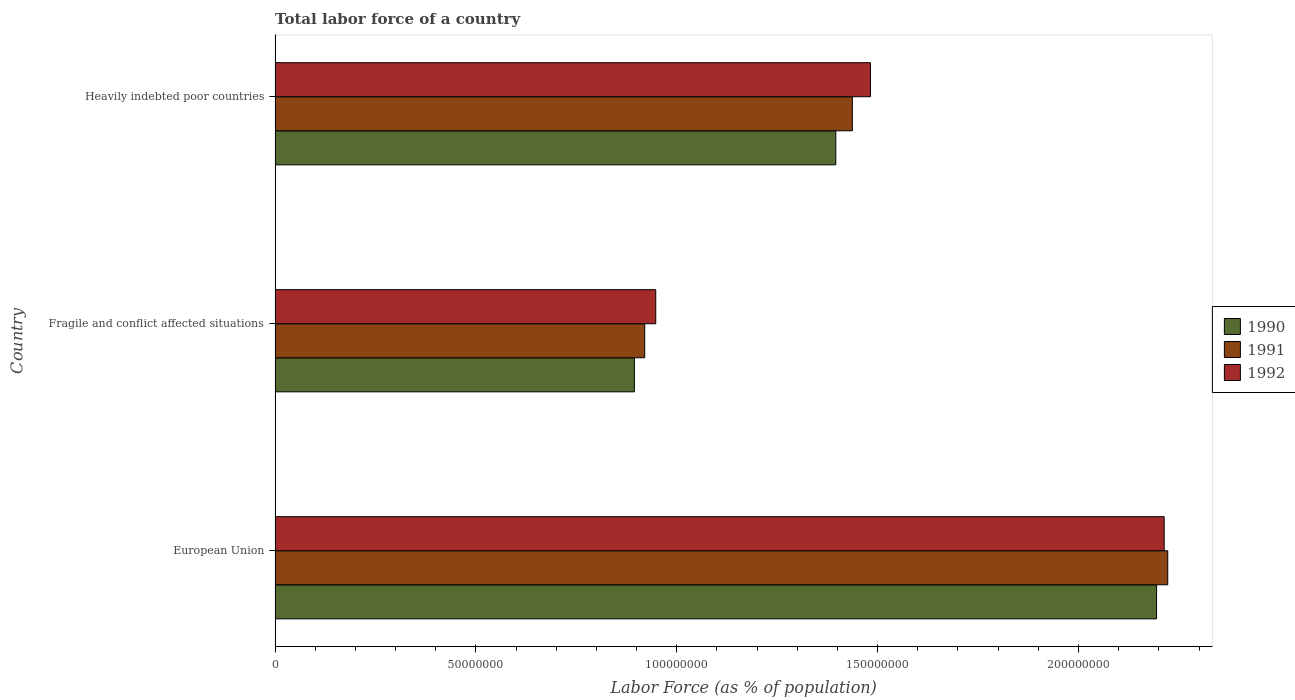Are the number of bars per tick equal to the number of legend labels?
Your response must be concise. Yes. Are the number of bars on each tick of the Y-axis equal?
Offer a terse response. Yes. How many bars are there on the 2nd tick from the top?
Make the answer very short. 3. How many bars are there on the 1st tick from the bottom?
Ensure brevity in your answer.  3. What is the percentage of labor force in 1992 in Fragile and conflict affected situations?
Provide a succinct answer. 9.48e+07. Across all countries, what is the maximum percentage of labor force in 1990?
Provide a succinct answer. 2.19e+08. Across all countries, what is the minimum percentage of labor force in 1991?
Offer a very short reply. 9.20e+07. In which country was the percentage of labor force in 1990 minimum?
Ensure brevity in your answer.  Fragile and conflict affected situations. What is the total percentage of labor force in 1990 in the graph?
Ensure brevity in your answer.  4.48e+08. What is the difference between the percentage of labor force in 1990 in European Union and that in Fragile and conflict affected situations?
Keep it short and to the point. 1.30e+08. What is the difference between the percentage of labor force in 1990 in European Union and the percentage of labor force in 1991 in Fragile and conflict affected situations?
Your answer should be very brief. 1.27e+08. What is the average percentage of labor force in 1992 per country?
Keep it short and to the point. 1.55e+08. What is the difference between the percentage of labor force in 1990 and percentage of labor force in 1991 in European Union?
Make the answer very short. -2.78e+06. What is the ratio of the percentage of labor force in 1990 in Fragile and conflict affected situations to that in Heavily indebted poor countries?
Provide a succinct answer. 0.64. Is the percentage of labor force in 1991 in European Union less than that in Heavily indebted poor countries?
Give a very brief answer. No. Is the difference between the percentage of labor force in 1990 in European Union and Fragile and conflict affected situations greater than the difference between the percentage of labor force in 1991 in European Union and Fragile and conflict affected situations?
Provide a short and direct response. No. What is the difference between the highest and the second highest percentage of labor force in 1991?
Keep it short and to the point. 7.85e+07. What is the difference between the highest and the lowest percentage of labor force in 1992?
Your response must be concise. 1.27e+08. In how many countries, is the percentage of labor force in 1992 greater than the average percentage of labor force in 1992 taken over all countries?
Make the answer very short. 1. Is the sum of the percentage of labor force in 1990 in European Union and Heavily indebted poor countries greater than the maximum percentage of labor force in 1991 across all countries?
Keep it short and to the point. Yes. What does the 3rd bar from the bottom in Heavily indebted poor countries represents?
Your response must be concise. 1992. How many countries are there in the graph?
Your answer should be compact. 3. What is the difference between two consecutive major ticks on the X-axis?
Your answer should be very brief. 5.00e+07. Are the values on the major ticks of X-axis written in scientific E-notation?
Offer a terse response. No. Does the graph contain grids?
Your answer should be compact. No. Where does the legend appear in the graph?
Offer a terse response. Center right. How are the legend labels stacked?
Keep it short and to the point. Vertical. What is the title of the graph?
Provide a short and direct response. Total labor force of a country. Does "1964" appear as one of the legend labels in the graph?
Your response must be concise. No. What is the label or title of the X-axis?
Offer a terse response. Labor Force (as % of population). What is the label or title of the Y-axis?
Give a very brief answer. Country. What is the Labor Force (as % of population) in 1990 in European Union?
Your answer should be compact. 2.19e+08. What is the Labor Force (as % of population) of 1991 in European Union?
Provide a short and direct response. 2.22e+08. What is the Labor Force (as % of population) in 1992 in European Union?
Your response must be concise. 2.21e+08. What is the Labor Force (as % of population) in 1990 in Fragile and conflict affected situations?
Your response must be concise. 8.94e+07. What is the Labor Force (as % of population) in 1991 in Fragile and conflict affected situations?
Provide a succinct answer. 9.20e+07. What is the Labor Force (as % of population) in 1992 in Fragile and conflict affected situations?
Your answer should be very brief. 9.48e+07. What is the Labor Force (as % of population) of 1990 in Heavily indebted poor countries?
Provide a succinct answer. 1.40e+08. What is the Labor Force (as % of population) of 1991 in Heavily indebted poor countries?
Keep it short and to the point. 1.44e+08. What is the Labor Force (as % of population) of 1992 in Heavily indebted poor countries?
Your answer should be compact. 1.48e+08. Across all countries, what is the maximum Labor Force (as % of population) of 1990?
Offer a terse response. 2.19e+08. Across all countries, what is the maximum Labor Force (as % of population) of 1991?
Keep it short and to the point. 2.22e+08. Across all countries, what is the maximum Labor Force (as % of population) of 1992?
Provide a short and direct response. 2.21e+08. Across all countries, what is the minimum Labor Force (as % of population) of 1990?
Make the answer very short. 8.94e+07. Across all countries, what is the minimum Labor Force (as % of population) in 1991?
Give a very brief answer. 9.20e+07. Across all countries, what is the minimum Labor Force (as % of population) of 1992?
Your answer should be very brief. 9.48e+07. What is the total Labor Force (as % of population) of 1990 in the graph?
Give a very brief answer. 4.48e+08. What is the total Labor Force (as % of population) of 1991 in the graph?
Provide a short and direct response. 4.58e+08. What is the total Labor Force (as % of population) in 1992 in the graph?
Your response must be concise. 4.64e+08. What is the difference between the Labor Force (as % of population) in 1990 in European Union and that in Fragile and conflict affected situations?
Offer a very short reply. 1.30e+08. What is the difference between the Labor Force (as % of population) in 1991 in European Union and that in Fragile and conflict affected situations?
Your answer should be very brief. 1.30e+08. What is the difference between the Labor Force (as % of population) of 1992 in European Union and that in Fragile and conflict affected situations?
Keep it short and to the point. 1.27e+08. What is the difference between the Labor Force (as % of population) of 1990 in European Union and that in Heavily indebted poor countries?
Provide a succinct answer. 7.99e+07. What is the difference between the Labor Force (as % of population) of 1991 in European Union and that in Heavily indebted poor countries?
Make the answer very short. 7.85e+07. What is the difference between the Labor Force (as % of population) in 1992 in European Union and that in Heavily indebted poor countries?
Your answer should be compact. 7.31e+07. What is the difference between the Labor Force (as % of population) in 1990 in Fragile and conflict affected situations and that in Heavily indebted poor countries?
Ensure brevity in your answer.  -5.01e+07. What is the difference between the Labor Force (as % of population) in 1991 in Fragile and conflict affected situations and that in Heavily indebted poor countries?
Keep it short and to the point. -5.17e+07. What is the difference between the Labor Force (as % of population) in 1992 in Fragile and conflict affected situations and that in Heavily indebted poor countries?
Provide a succinct answer. -5.34e+07. What is the difference between the Labor Force (as % of population) of 1990 in European Union and the Labor Force (as % of population) of 1991 in Fragile and conflict affected situations?
Provide a short and direct response. 1.27e+08. What is the difference between the Labor Force (as % of population) of 1990 in European Union and the Labor Force (as % of population) of 1992 in Fragile and conflict affected situations?
Your answer should be very brief. 1.25e+08. What is the difference between the Labor Force (as % of population) of 1991 in European Union and the Labor Force (as % of population) of 1992 in Fragile and conflict affected situations?
Provide a succinct answer. 1.27e+08. What is the difference between the Labor Force (as % of population) in 1990 in European Union and the Labor Force (as % of population) in 1991 in Heavily indebted poor countries?
Keep it short and to the point. 7.57e+07. What is the difference between the Labor Force (as % of population) in 1990 in European Union and the Labor Force (as % of population) in 1992 in Heavily indebted poor countries?
Offer a very short reply. 7.12e+07. What is the difference between the Labor Force (as % of population) in 1991 in European Union and the Labor Force (as % of population) in 1992 in Heavily indebted poor countries?
Make the answer very short. 7.40e+07. What is the difference between the Labor Force (as % of population) in 1990 in Fragile and conflict affected situations and the Labor Force (as % of population) in 1991 in Heavily indebted poor countries?
Provide a short and direct response. -5.43e+07. What is the difference between the Labor Force (as % of population) in 1990 in Fragile and conflict affected situations and the Labor Force (as % of population) in 1992 in Heavily indebted poor countries?
Ensure brevity in your answer.  -5.88e+07. What is the difference between the Labor Force (as % of population) of 1991 in Fragile and conflict affected situations and the Labor Force (as % of population) of 1992 in Heavily indebted poor countries?
Keep it short and to the point. -5.62e+07. What is the average Labor Force (as % of population) in 1990 per country?
Your answer should be compact. 1.49e+08. What is the average Labor Force (as % of population) in 1991 per country?
Ensure brevity in your answer.  1.53e+08. What is the average Labor Force (as % of population) of 1992 per country?
Provide a succinct answer. 1.55e+08. What is the difference between the Labor Force (as % of population) in 1990 and Labor Force (as % of population) in 1991 in European Union?
Your answer should be very brief. -2.78e+06. What is the difference between the Labor Force (as % of population) of 1990 and Labor Force (as % of population) of 1992 in European Union?
Provide a succinct answer. -1.89e+06. What is the difference between the Labor Force (as % of population) in 1991 and Labor Force (as % of population) in 1992 in European Union?
Keep it short and to the point. 8.88e+05. What is the difference between the Labor Force (as % of population) of 1990 and Labor Force (as % of population) of 1991 in Fragile and conflict affected situations?
Provide a short and direct response. -2.58e+06. What is the difference between the Labor Force (as % of population) in 1990 and Labor Force (as % of population) in 1992 in Fragile and conflict affected situations?
Ensure brevity in your answer.  -5.32e+06. What is the difference between the Labor Force (as % of population) of 1991 and Labor Force (as % of population) of 1992 in Fragile and conflict affected situations?
Keep it short and to the point. -2.74e+06. What is the difference between the Labor Force (as % of population) of 1990 and Labor Force (as % of population) of 1991 in Heavily indebted poor countries?
Keep it short and to the point. -4.12e+06. What is the difference between the Labor Force (as % of population) of 1990 and Labor Force (as % of population) of 1992 in Heavily indebted poor countries?
Offer a very short reply. -8.62e+06. What is the difference between the Labor Force (as % of population) in 1991 and Labor Force (as % of population) in 1992 in Heavily indebted poor countries?
Give a very brief answer. -4.50e+06. What is the ratio of the Labor Force (as % of population) of 1990 in European Union to that in Fragile and conflict affected situations?
Make the answer very short. 2.45. What is the ratio of the Labor Force (as % of population) in 1991 in European Union to that in Fragile and conflict affected situations?
Offer a very short reply. 2.41. What is the ratio of the Labor Force (as % of population) of 1992 in European Union to that in Fragile and conflict affected situations?
Give a very brief answer. 2.34. What is the ratio of the Labor Force (as % of population) of 1990 in European Union to that in Heavily indebted poor countries?
Keep it short and to the point. 1.57. What is the ratio of the Labor Force (as % of population) in 1991 in European Union to that in Heavily indebted poor countries?
Your response must be concise. 1.55. What is the ratio of the Labor Force (as % of population) in 1992 in European Union to that in Heavily indebted poor countries?
Give a very brief answer. 1.49. What is the ratio of the Labor Force (as % of population) in 1990 in Fragile and conflict affected situations to that in Heavily indebted poor countries?
Offer a very short reply. 0.64. What is the ratio of the Labor Force (as % of population) in 1991 in Fragile and conflict affected situations to that in Heavily indebted poor countries?
Give a very brief answer. 0.64. What is the ratio of the Labor Force (as % of population) of 1992 in Fragile and conflict affected situations to that in Heavily indebted poor countries?
Provide a succinct answer. 0.64. What is the difference between the highest and the second highest Labor Force (as % of population) in 1990?
Your answer should be compact. 7.99e+07. What is the difference between the highest and the second highest Labor Force (as % of population) in 1991?
Make the answer very short. 7.85e+07. What is the difference between the highest and the second highest Labor Force (as % of population) of 1992?
Provide a succinct answer. 7.31e+07. What is the difference between the highest and the lowest Labor Force (as % of population) of 1990?
Provide a short and direct response. 1.30e+08. What is the difference between the highest and the lowest Labor Force (as % of population) in 1991?
Your answer should be compact. 1.30e+08. What is the difference between the highest and the lowest Labor Force (as % of population) in 1992?
Provide a short and direct response. 1.27e+08. 